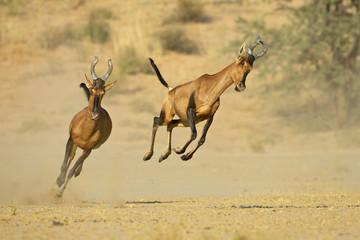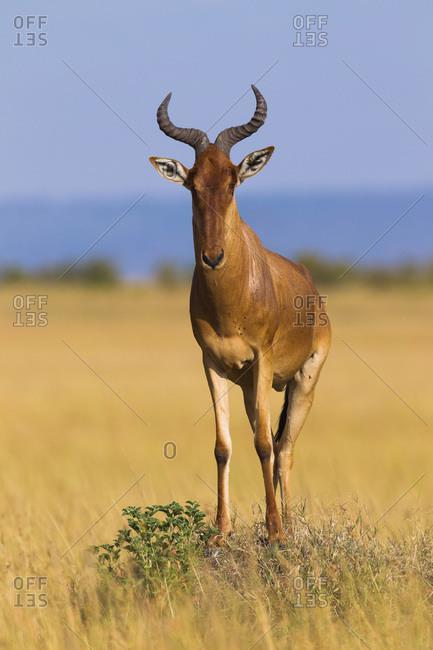The first image is the image on the left, the second image is the image on the right. Given the left and right images, does the statement "There are at most two hartebeests." hold true? Answer yes or no. No. The first image is the image on the left, the second image is the image on the right. Assess this claim about the two images: "At least one antelope has its legs up in the air.". Correct or not? Answer yes or no. Yes. 